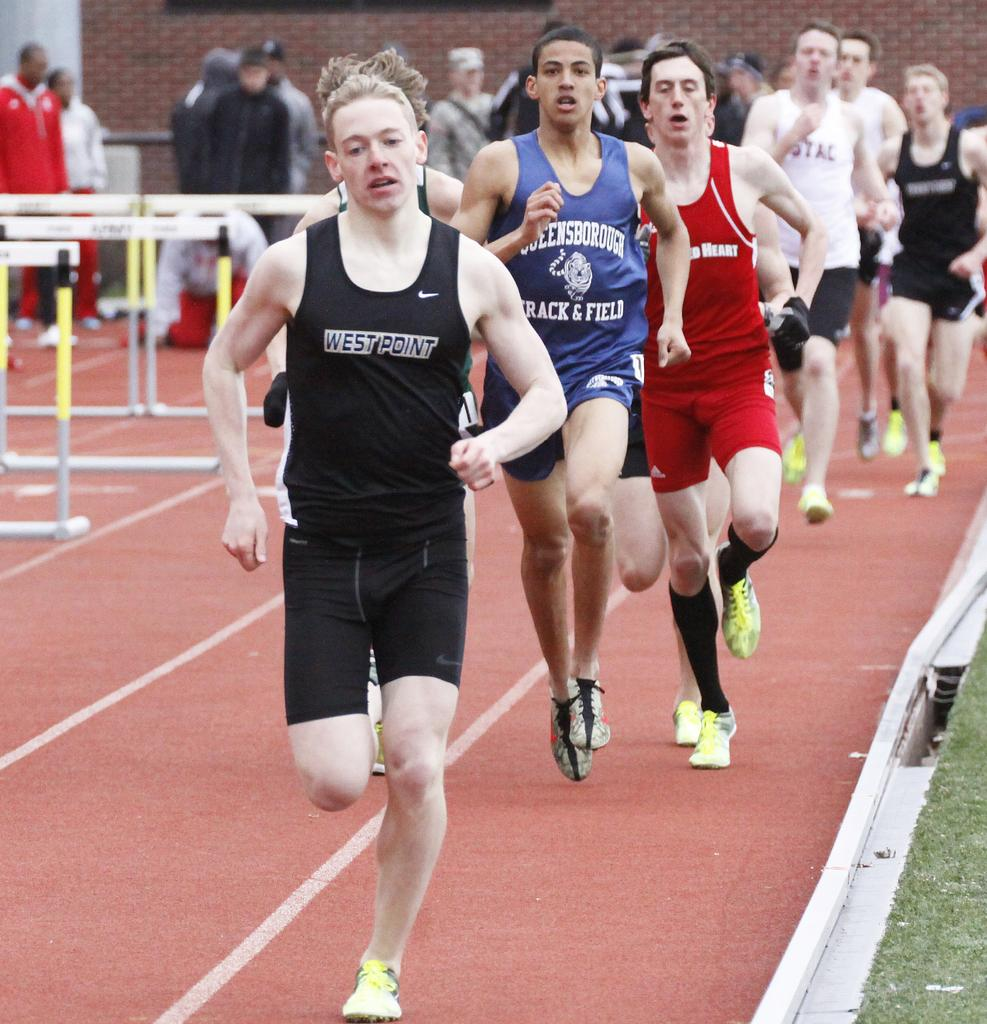What are the people in the image doing? There are many people running on the track in the image. Can you describe the background of the image? There are people and at least one building in the background of the image. What obstacles are present on the track? There are hurdles present on the track. Where is the map located in the image? There is no map present in the image. Can you describe the ants' behavior in the image? There are no ants present in the image. 